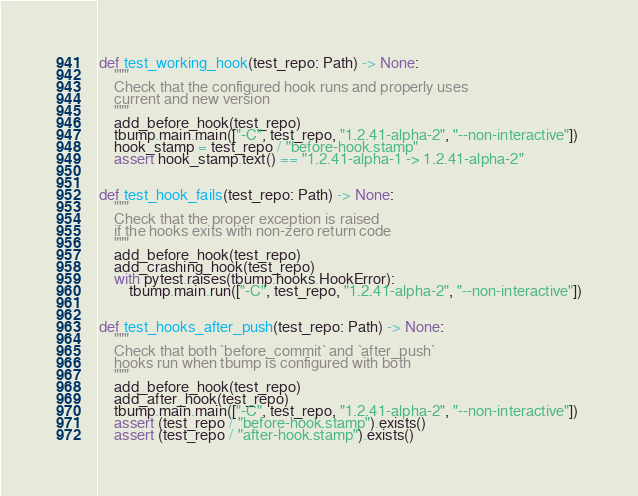<code> <loc_0><loc_0><loc_500><loc_500><_Python_>
def test_working_hook(test_repo: Path) -> None:
    """
    Check that the configured hook runs and properly uses
    current and new version
    """
    add_before_hook(test_repo)
    tbump.main.main(["-C", test_repo, "1.2.41-alpha-2", "--non-interactive"])
    hook_stamp = test_repo / "before-hook.stamp"
    assert hook_stamp.text() == "1.2.41-alpha-1 -> 1.2.41-alpha-2"


def test_hook_fails(test_repo: Path) -> None:
    """
    Check that the proper exception is raised
    if the hooks exits with non-zero return code
    """
    add_before_hook(test_repo)
    add_crashing_hook(test_repo)
    with pytest.raises(tbump.hooks.HookError):
        tbump.main.run(["-C", test_repo, "1.2.41-alpha-2", "--non-interactive"])


def test_hooks_after_push(test_repo: Path) -> None:
    """
    Check that both `before_commit` and `after_push`
    hooks run when tbump is configured with both
    """
    add_before_hook(test_repo)
    add_after_hook(test_repo)
    tbump.main.main(["-C", test_repo, "1.2.41-alpha-2", "--non-interactive"])
    assert (test_repo / "before-hook.stamp").exists()
    assert (test_repo / "after-hook.stamp").exists()
</code> 